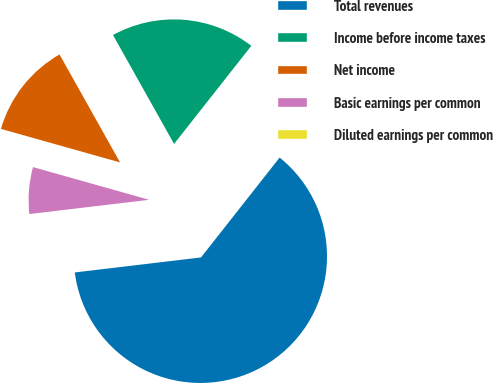<chart> <loc_0><loc_0><loc_500><loc_500><pie_chart><fcel>Total revenues<fcel>Income before income taxes<fcel>Net income<fcel>Basic earnings per common<fcel>Diluted earnings per common<nl><fcel>62.5%<fcel>18.75%<fcel>12.5%<fcel>6.25%<fcel>0.0%<nl></chart> 